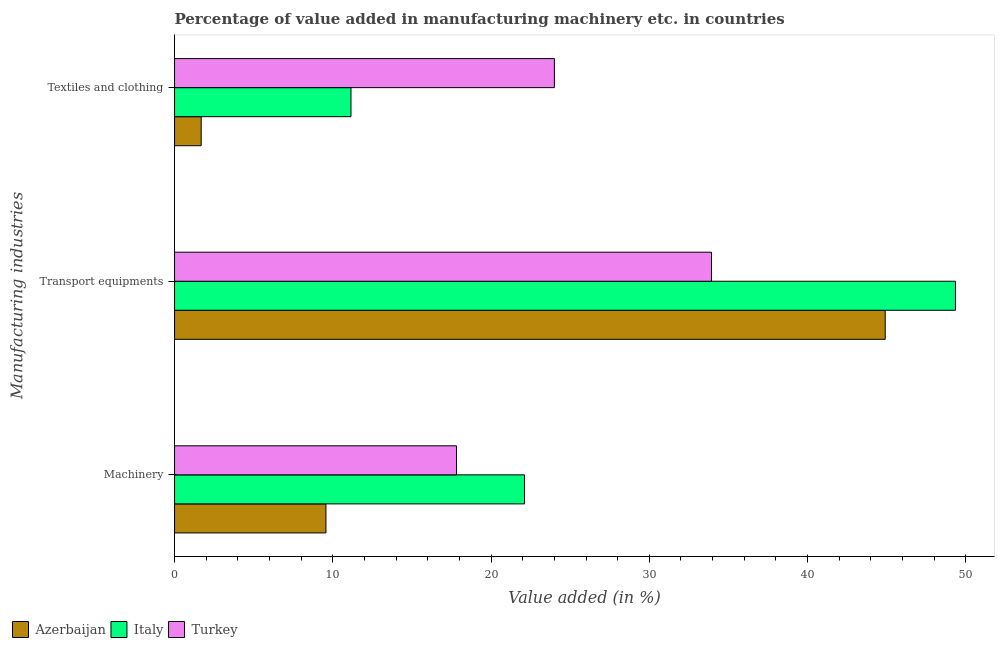Are the number of bars on each tick of the Y-axis equal?
Make the answer very short. Yes. How many bars are there on the 2nd tick from the top?
Your answer should be very brief. 3. How many bars are there on the 1st tick from the bottom?
Ensure brevity in your answer.  3. What is the label of the 3rd group of bars from the top?
Ensure brevity in your answer.  Machinery. What is the value added in manufacturing machinery in Italy?
Give a very brief answer. 22.12. Across all countries, what is the maximum value added in manufacturing transport equipments?
Keep it short and to the point. 49.35. Across all countries, what is the minimum value added in manufacturing textile and clothing?
Your response must be concise. 1.68. In which country was the value added in manufacturing textile and clothing minimum?
Your answer should be very brief. Azerbaijan. What is the total value added in manufacturing machinery in the graph?
Give a very brief answer. 49.5. What is the difference between the value added in manufacturing machinery in Italy and that in Azerbaijan?
Ensure brevity in your answer.  12.55. What is the difference between the value added in manufacturing textile and clothing in Azerbaijan and the value added in manufacturing machinery in Italy?
Your answer should be compact. -20.43. What is the average value added in manufacturing transport equipments per country?
Offer a terse response. 42.73. What is the difference between the value added in manufacturing machinery and value added in manufacturing textile and clothing in Italy?
Your response must be concise. 10.97. What is the ratio of the value added in manufacturing transport equipments in Azerbaijan to that in Italy?
Provide a succinct answer. 0.91. Is the value added in manufacturing transport equipments in Azerbaijan less than that in Turkey?
Provide a succinct answer. No. Is the difference between the value added in manufacturing transport equipments in Azerbaijan and Italy greater than the difference between the value added in manufacturing textile and clothing in Azerbaijan and Italy?
Make the answer very short. Yes. What is the difference between the highest and the second highest value added in manufacturing transport equipments?
Your answer should be very brief. 4.44. What is the difference between the highest and the lowest value added in manufacturing machinery?
Your answer should be compact. 12.55. In how many countries, is the value added in manufacturing transport equipments greater than the average value added in manufacturing transport equipments taken over all countries?
Your answer should be compact. 2. Is the sum of the value added in manufacturing textile and clothing in Turkey and Italy greater than the maximum value added in manufacturing transport equipments across all countries?
Give a very brief answer. No. What does the 2nd bar from the top in Machinery represents?
Your answer should be very brief. Italy. Is it the case that in every country, the sum of the value added in manufacturing machinery and value added in manufacturing transport equipments is greater than the value added in manufacturing textile and clothing?
Your response must be concise. Yes. How many bars are there?
Offer a terse response. 9. How are the legend labels stacked?
Keep it short and to the point. Horizontal. What is the title of the graph?
Your answer should be very brief. Percentage of value added in manufacturing machinery etc. in countries. What is the label or title of the X-axis?
Your answer should be compact. Value added (in %). What is the label or title of the Y-axis?
Ensure brevity in your answer.  Manufacturing industries. What is the Value added (in %) of Azerbaijan in Machinery?
Your response must be concise. 9.57. What is the Value added (in %) in Italy in Machinery?
Your answer should be very brief. 22.12. What is the Value added (in %) in Turkey in Machinery?
Keep it short and to the point. 17.82. What is the Value added (in %) of Azerbaijan in Transport equipments?
Make the answer very short. 44.91. What is the Value added (in %) in Italy in Transport equipments?
Provide a succinct answer. 49.35. What is the Value added (in %) in Turkey in Transport equipments?
Keep it short and to the point. 33.93. What is the Value added (in %) of Azerbaijan in Textiles and clothing?
Your answer should be very brief. 1.68. What is the Value added (in %) of Italy in Textiles and clothing?
Provide a short and direct response. 11.15. What is the Value added (in %) of Turkey in Textiles and clothing?
Your answer should be compact. 24. Across all Manufacturing industries, what is the maximum Value added (in %) of Azerbaijan?
Keep it short and to the point. 44.91. Across all Manufacturing industries, what is the maximum Value added (in %) in Italy?
Provide a succinct answer. 49.35. Across all Manufacturing industries, what is the maximum Value added (in %) in Turkey?
Keep it short and to the point. 33.93. Across all Manufacturing industries, what is the minimum Value added (in %) of Azerbaijan?
Your answer should be very brief. 1.68. Across all Manufacturing industries, what is the minimum Value added (in %) in Italy?
Your answer should be very brief. 11.15. Across all Manufacturing industries, what is the minimum Value added (in %) of Turkey?
Your answer should be compact. 17.82. What is the total Value added (in %) in Azerbaijan in the graph?
Your answer should be compact. 56.16. What is the total Value added (in %) of Italy in the graph?
Your response must be concise. 82.61. What is the total Value added (in %) of Turkey in the graph?
Give a very brief answer. 75.75. What is the difference between the Value added (in %) of Azerbaijan in Machinery and that in Transport equipments?
Give a very brief answer. -35.34. What is the difference between the Value added (in %) in Italy in Machinery and that in Transport equipments?
Offer a very short reply. -27.23. What is the difference between the Value added (in %) in Turkey in Machinery and that in Transport equipments?
Provide a short and direct response. -16.11. What is the difference between the Value added (in %) of Azerbaijan in Machinery and that in Textiles and clothing?
Offer a very short reply. 7.88. What is the difference between the Value added (in %) in Italy in Machinery and that in Textiles and clothing?
Your answer should be compact. 10.97. What is the difference between the Value added (in %) of Turkey in Machinery and that in Textiles and clothing?
Give a very brief answer. -6.19. What is the difference between the Value added (in %) of Azerbaijan in Transport equipments and that in Textiles and clothing?
Offer a terse response. 43.22. What is the difference between the Value added (in %) in Italy in Transport equipments and that in Textiles and clothing?
Keep it short and to the point. 38.2. What is the difference between the Value added (in %) in Turkey in Transport equipments and that in Textiles and clothing?
Make the answer very short. 9.93. What is the difference between the Value added (in %) of Azerbaijan in Machinery and the Value added (in %) of Italy in Transport equipments?
Offer a terse response. -39.78. What is the difference between the Value added (in %) in Azerbaijan in Machinery and the Value added (in %) in Turkey in Transport equipments?
Offer a very short reply. -24.36. What is the difference between the Value added (in %) of Italy in Machinery and the Value added (in %) of Turkey in Transport equipments?
Offer a very short reply. -11.81. What is the difference between the Value added (in %) in Azerbaijan in Machinery and the Value added (in %) in Italy in Textiles and clothing?
Ensure brevity in your answer.  -1.58. What is the difference between the Value added (in %) of Azerbaijan in Machinery and the Value added (in %) of Turkey in Textiles and clothing?
Offer a very short reply. -14.44. What is the difference between the Value added (in %) of Italy in Machinery and the Value added (in %) of Turkey in Textiles and clothing?
Make the answer very short. -1.89. What is the difference between the Value added (in %) in Azerbaijan in Transport equipments and the Value added (in %) in Italy in Textiles and clothing?
Provide a short and direct response. 33.76. What is the difference between the Value added (in %) of Azerbaijan in Transport equipments and the Value added (in %) of Turkey in Textiles and clothing?
Provide a short and direct response. 20.9. What is the difference between the Value added (in %) of Italy in Transport equipments and the Value added (in %) of Turkey in Textiles and clothing?
Your answer should be compact. 25.34. What is the average Value added (in %) in Azerbaijan per Manufacturing industries?
Offer a very short reply. 18.72. What is the average Value added (in %) of Italy per Manufacturing industries?
Your response must be concise. 27.54. What is the average Value added (in %) of Turkey per Manufacturing industries?
Provide a succinct answer. 25.25. What is the difference between the Value added (in %) in Azerbaijan and Value added (in %) in Italy in Machinery?
Ensure brevity in your answer.  -12.55. What is the difference between the Value added (in %) in Azerbaijan and Value added (in %) in Turkey in Machinery?
Your answer should be very brief. -8.25. What is the difference between the Value added (in %) of Italy and Value added (in %) of Turkey in Machinery?
Ensure brevity in your answer.  4.3. What is the difference between the Value added (in %) in Azerbaijan and Value added (in %) in Italy in Transport equipments?
Provide a succinct answer. -4.44. What is the difference between the Value added (in %) of Azerbaijan and Value added (in %) of Turkey in Transport equipments?
Provide a short and direct response. 10.98. What is the difference between the Value added (in %) of Italy and Value added (in %) of Turkey in Transport equipments?
Give a very brief answer. 15.42. What is the difference between the Value added (in %) of Azerbaijan and Value added (in %) of Italy in Textiles and clothing?
Your answer should be very brief. -9.47. What is the difference between the Value added (in %) in Azerbaijan and Value added (in %) in Turkey in Textiles and clothing?
Make the answer very short. -22.32. What is the difference between the Value added (in %) of Italy and Value added (in %) of Turkey in Textiles and clothing?
Ensure brevity in your answer.  -12.85. What is the ratio of the Value added (in %) of Azerbaijan in Machinery to that in Transport equipments?
Offer a very short reply. 0.21. What is the ratio of the Value added (in %) in Italy in Machinery to that in Transport equipments?
Ensure brevity in your answer.  0.45. What is the ratio of the Value added (in %) of Turkey in Machinery to that in Transport equipments?
Provide a short and direct response. 0.53. What is the ratio of the Value added (in %) of Azerbaijan in Machinery to that in Textiles and clothing?
Your answer should be compact. 5.68. What is the ratio of the Value added (in %) of Italy in Machinery to that in Textiles and clothing?
Keep it short and to the point. 1.98. What is the ratio of the Value added (in %) in Turkey in Machinery to that in Textiles and clothing?
Offer a terse response. 0.74. What is the ratio of the Value added (in %) in Azerbaijan in Transport equipments to that in Textiles and clothing?
Your response must be concise. 26.67. What is the ratio of the Value added (in %) in Italy in Transport equipments to that in Textiles and clothing?
Provide a short and direct response. 4.43. What is the ratio of the Value added (in %) in Turkey in Transport equipments to that in Textiles and clothing?
Keep it short and to the point. 1.41. What is the difference between the highest and the second highest Value added (in %) of Azerbaijan?
Offer a terse response. 35.34. What is the difference between the highest and the second highest Value added (in %) in Italy?
Your answer should be compact. 27.23. What is the difference between the highest and the second highest Value added (in %) of Turkey?
Your answer should be very brief. 9.93. What is the difference between the highest and the lowest Value added (in %) in Azerbaijan?
Ensure brevity in your answer.  43.22. What is the difference between the highest and the lowest Value added (in %) in Italy?
Make the answer very short. 38.2. What is the difference between the highest and the lowest Value added (in %) in Turkey?
Keep it short and to the point. 16.11. 